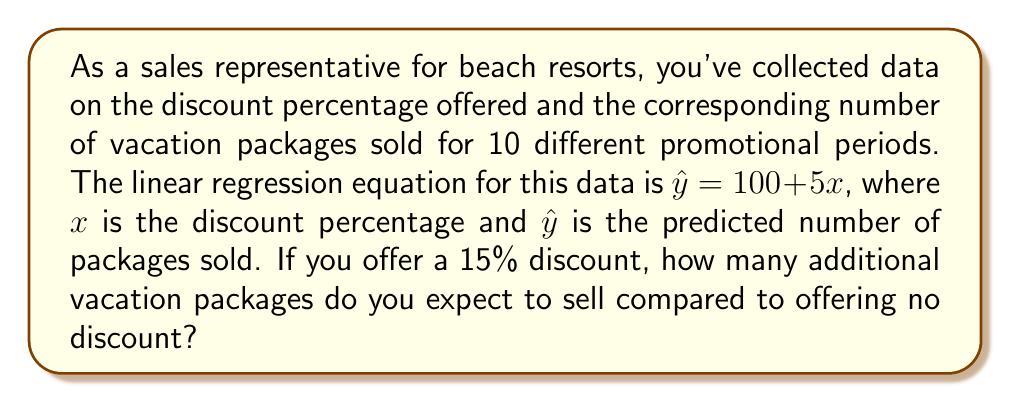What is the answer to this math problem? Let's approach this step-by-step:

1) The regression equation is given as:
   $$\hat{y} = 100 + 5x$$
   Where $x$ is the discount percentage and $\hat{y}$ is the predicted number of packages sold.

2) To find the number of packages sold with no discount, we substitute $x = 0$:
   $$\hat{y} = 100 + 5(0) = 100$$

3) To find the number of packages sold with a 15% discount, we substitute $x = 15$:
   $$\hat{y} = 100 + 5(15) = 100 + 75 = 175$$

4) To find the additional packages sold, we subtract the number sold with no discount from the number sold with 15% discount:
   $$175 - 100 = 75$$

Therefore, offering a 15% discount is expected to result in 75 additional vacation packages sold compared to offering no discount.
Answer: 75 additional packages 